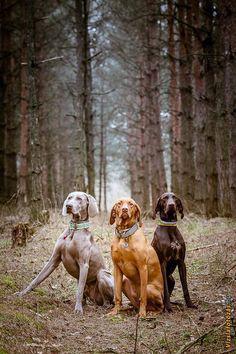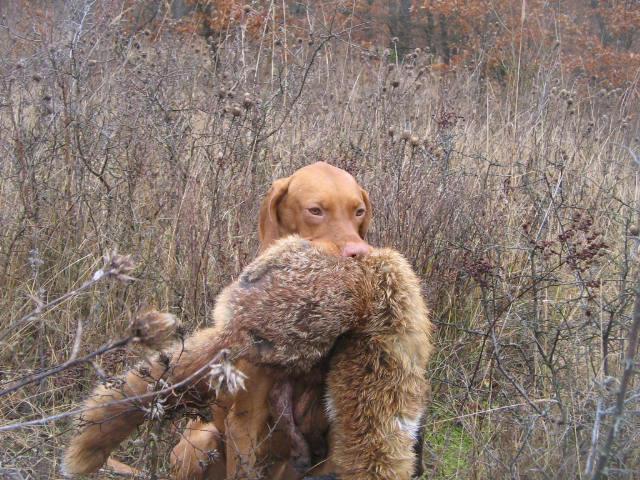The first image is the image on the left, the second image is the image on the right. Assess this claim about the two images: "There is one dog in the left image and multiple dogs in the right image.". Correct or not? Answer yes or no. No. The first image is the image on the left, the second image is the image on the right. Examine the images to the left and right. Is the description "One image shows a single puppy while the other shows a litter of at least five." accurate? Answer yes or no. No. 